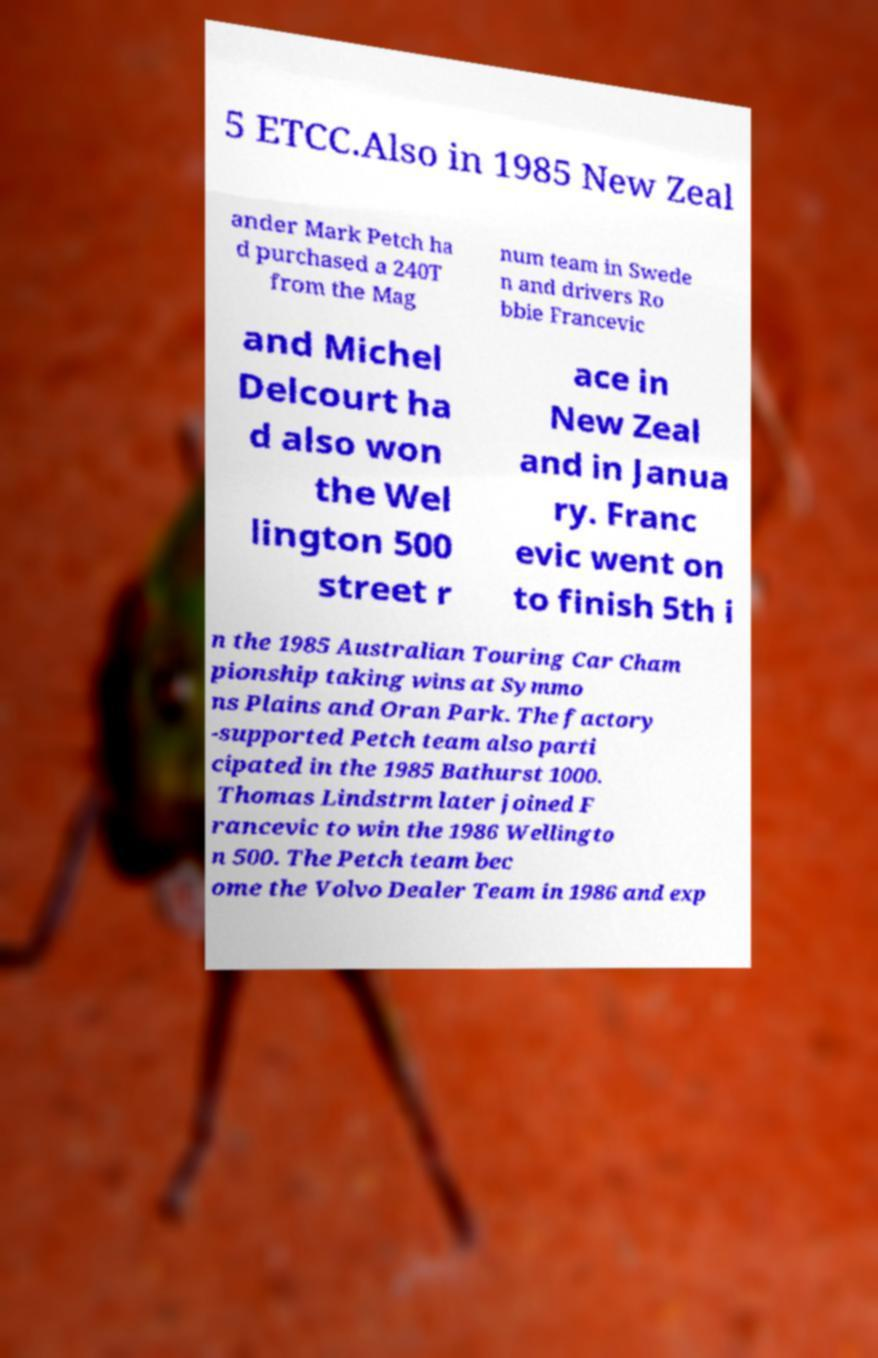For documentation purposes, I need the text within this image transcribed. Could you provide that? 5 ETCC.Also in 1985 New Zeal ander Mark Petch ha d purchased a 240T from the Mag num team in Swede n and drivers Ro bbie Francevic and Michel Delcourt ha d also won the Wel lington 500 street r ace in New Zeal and in Janua ry. Franc evic went on to finish 5th i n the 1985 Australian Touring Car Cham pionship taking wins at Symmo ns Plains and Oran Park. The factory -supported Petch team also parti cipated in the 1985 Bathurst 1000. Thomas Lindstrm later joined F rancevic to win the 1986 Wellingto n 500. The Petch team bec ome the Volvo Dealer Team in 1986 and exp 